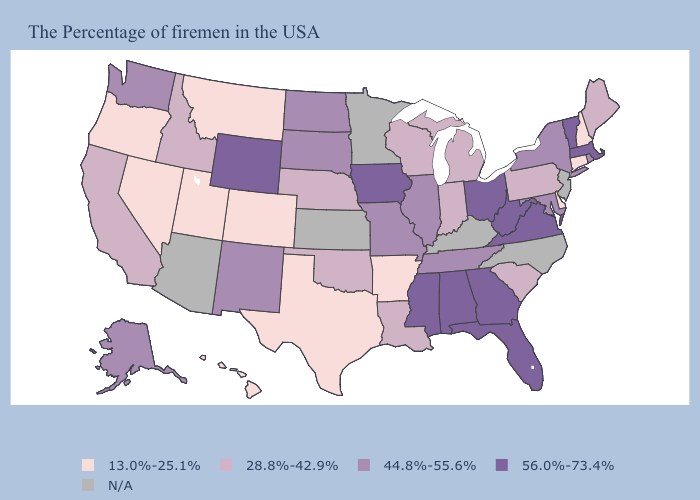Which states have the highest value in the USA?
Concise answer only. Massachusetts, Vermont, Virginia, West Virginia, Ohio, Florida, Georgia, Alabama, Mississippi, Iowa, Wyoming. What is the highest value in the USA?
Answer briefly. 56.0%-73.4%. Which states have the lowest value in the USA?
Keep it brief. New Hampshire, Connecticut, Delaware, Arkansas, Texas, Colorado, Utah, Montana, Nevada, Oregon, Hawaii. Does the first symbol in the legend represent the smallest category?
Quick response, please. Yes. What is the value of Nebraska?
Short answer required. 28.8%-42.9%. Name the states that have a value in the range 28.8%-42.9%?
Quick response, please. Maine, Pennsylvania, South Carolina, Michigan, Indiana, Wisconsin, Louisiana, Nebraska, Oklahoma, Idaho, California. Does North Dakota have the lowest value in the MidWest?
Concise answer only. No. Among the states that border Missouri , does Arkansas have the highest value?
Write a very short answer. No. Does Oregon have the lowest value in the USA?
Concise answer only. Yes. Among the states that border Colorado , does New Mexico have the lowest value?
Answer briefly. No. Among the states that border Louisiana , which have the highest value?
Keep it brief. Mississippi. Name the states that have a value in the range 28.8%-42.9%?
Concise answer only. Maine, Pennsylvania, South Carolina, Michigan, Indiana, Wisconsin, Louisiana, Nebraska, Oklahoma, Idaho, California. What is the value of Minnesota?
Keep it brief. N/A. Name the states that have a value in the range 13.0%-25.1%?
Answer briefly. New Hampshire, Connecticut, Delaware, Arkansas, Texas, Colorado, Utah, Montana, Nevada, Oregon, Hawaii. 